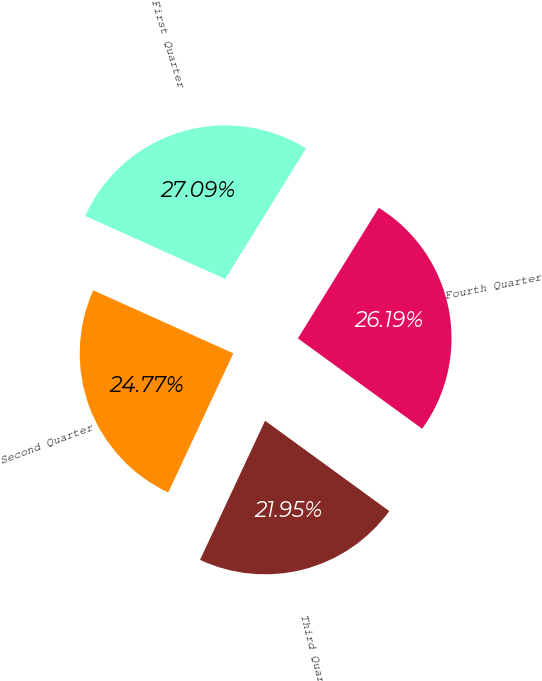<chart> <loc_0><loc_0><loc_500><loc_500><pie_chart><fcel>First Quarter<fcel>Second Quarter<fcel>Third Quarter<fcel>Fourth Quarter<nl><fcel>27.09%<fcel>24.77%<fcel>21.95%<fcel>26.19%<nl></chart> 